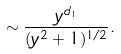Convert formula to latex. <formula><loc_0><loc_0><loc_500><loc_500>\sim \frac { y ^ { d _ { 1 } } } { ( y ^ { 2 } + 1 ) ^ { 1 / 2 } } .</formula> 